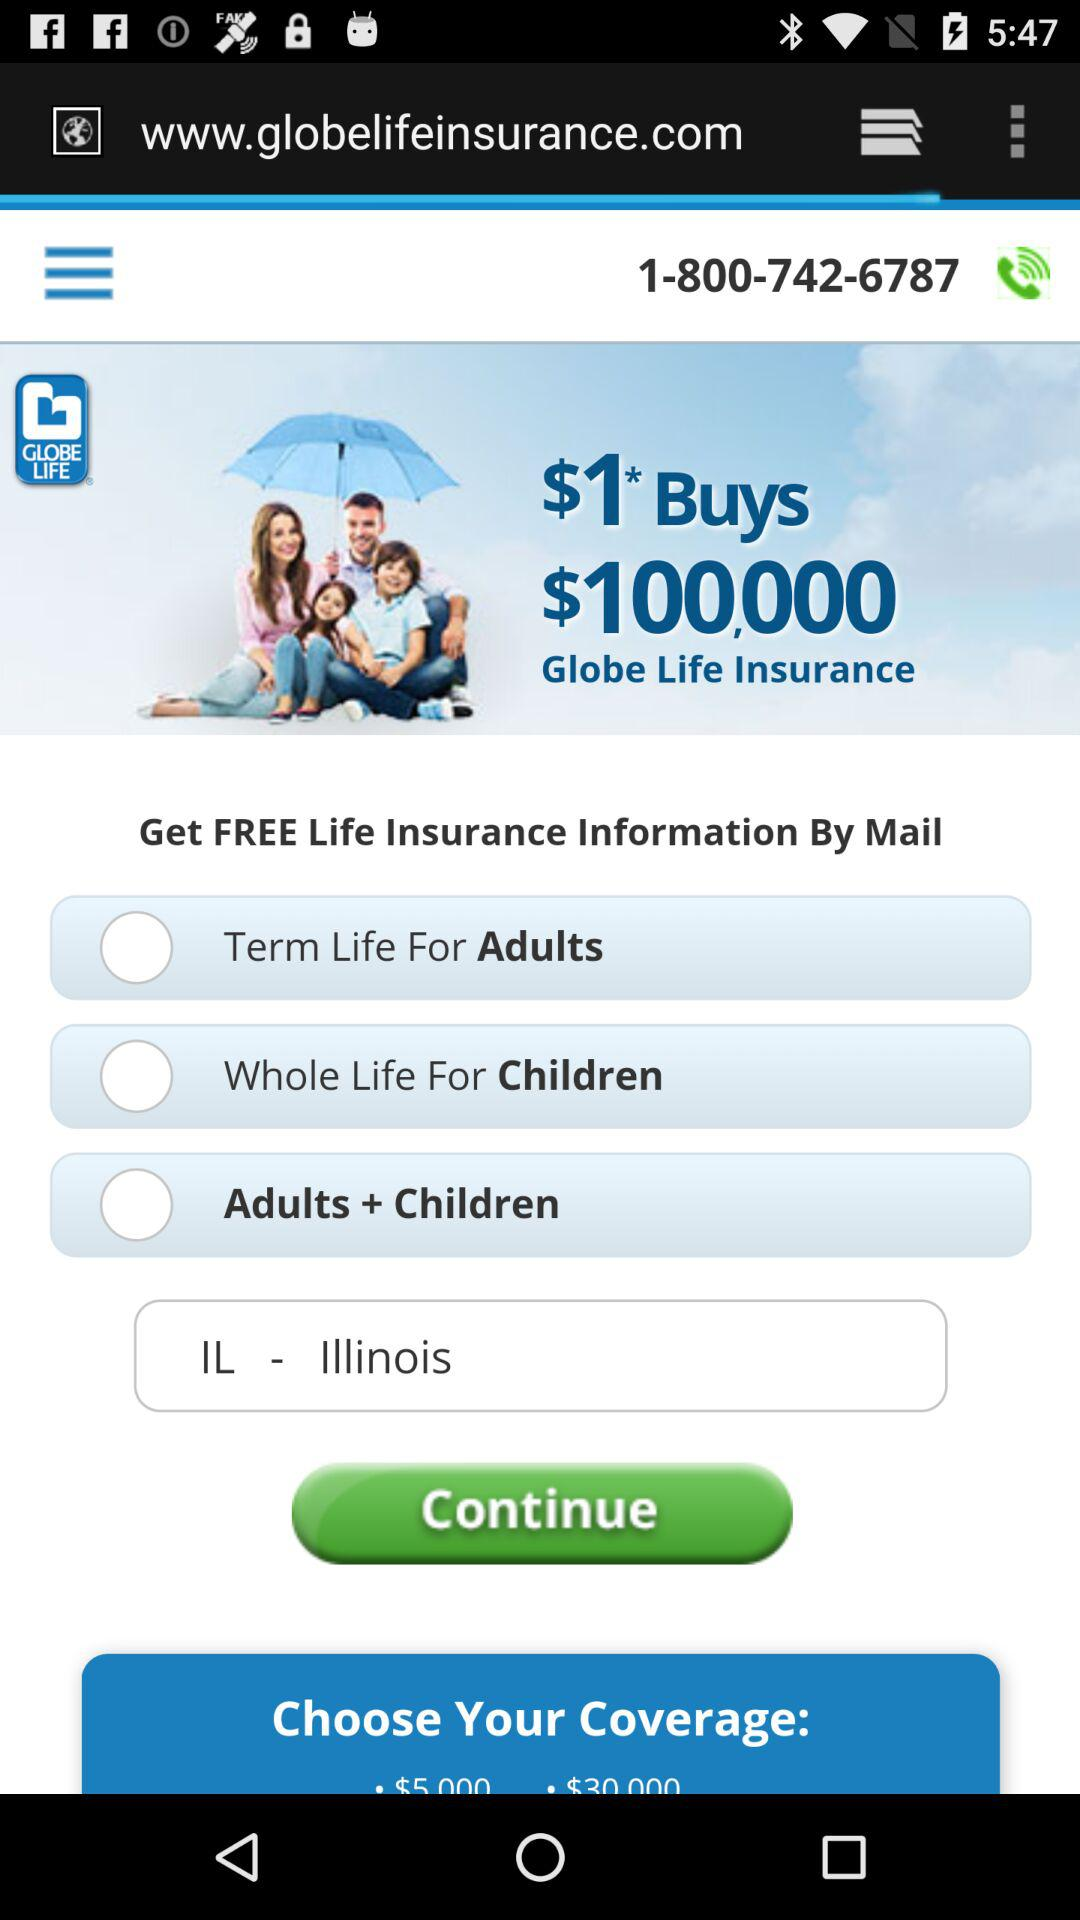What information do I need to provide to get a quote? To get a quote, it looks like you would need to select the type of coverage you're interested in and provide your state of residence as indicated by the dropdown menu for states. Is there any cost for the information provided by mail? The image suggests that the life insurance information by mail is free, as it states, 'Get FREE Life Insurance Information By Mail.' 